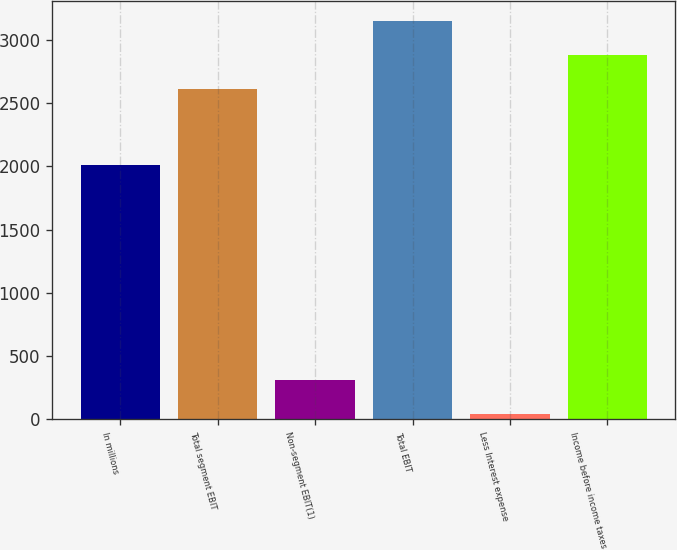<chart> <loc_0><loc_0><loc_500><loc_500><bar_chart><fcel>In millions<fcel>Total segment EBIT<fcel>Non-segment EBIT(1)<fcel>Total EBIT<fcel>Less Interest expense<fcel>Income before income taxes<nl><fcel>2011<fcel>2613<fcel>311.1<fcel>3147.2<fcel>44<fcel>2880.1<nl></chart> 